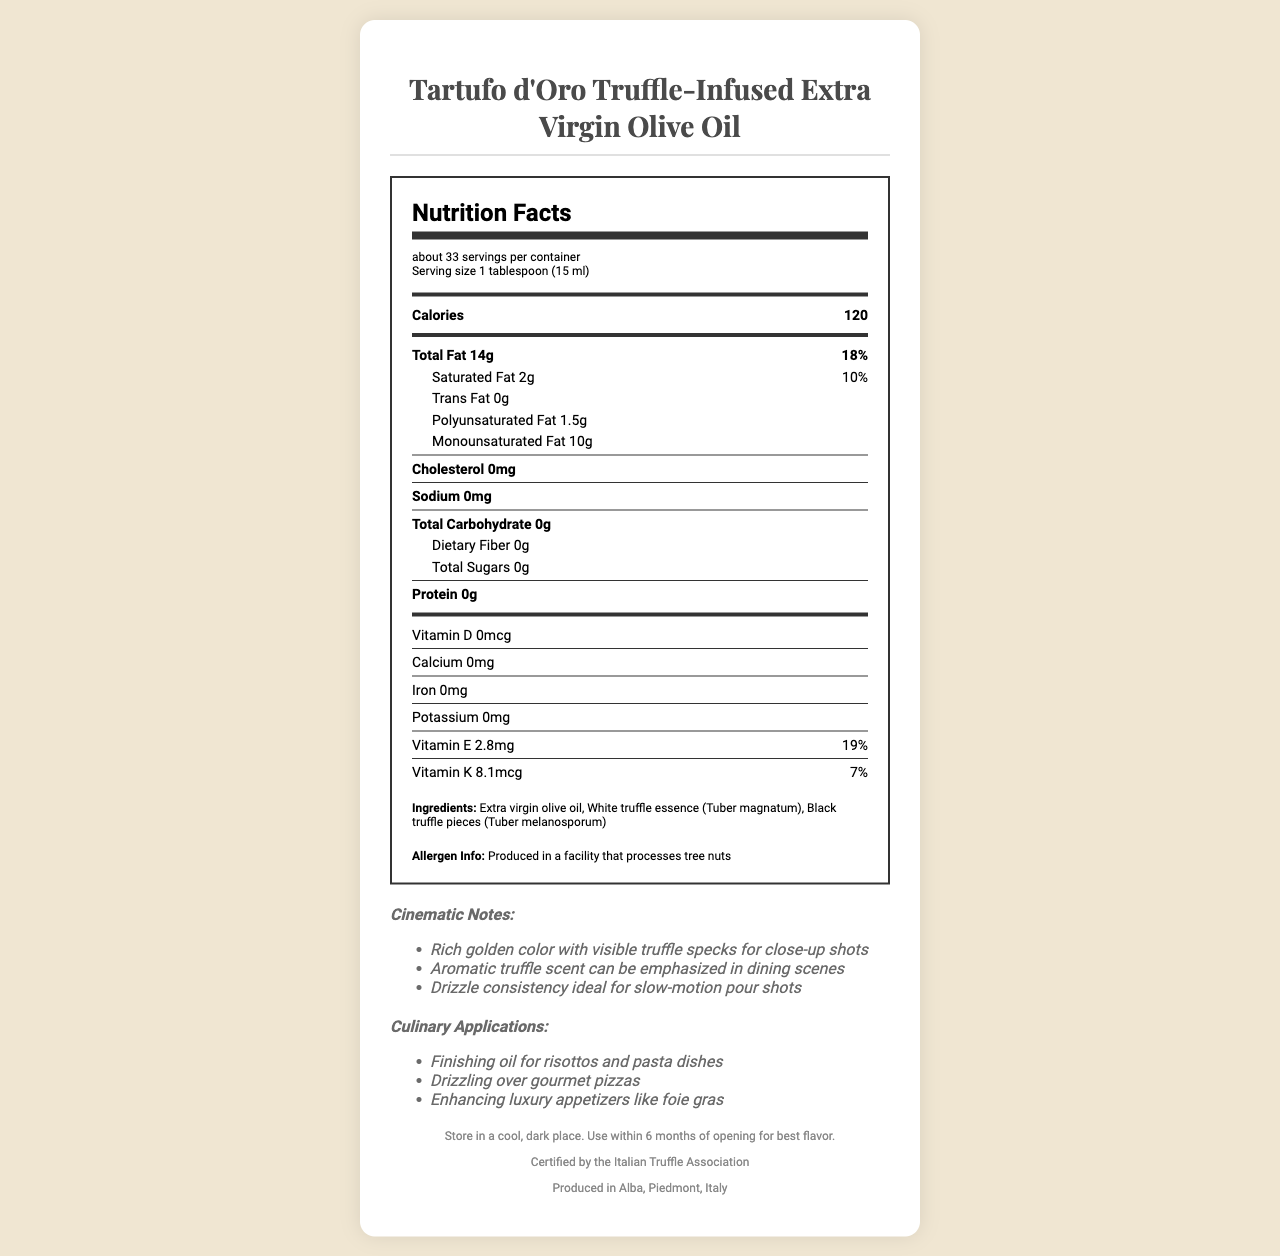who produces the Tartufo d'Oro Truffle-Infused Extra Virgin Olive Oil? The footer of the document states that the product is produced in Alba, Piedmont, Italy.
Answer: Produced in Alba, Piedmont, Italy how many calories are in one serving of the truffle-infused olive oil? The nutrition label specifies that there are 120 calories per 1 tablespoon (15 ml) serving.
Answer: 120 calories what is the main ingredient in this olive oil? The ingredients list starts with extra virgin olive oil, indicating it is the main ingredient.
Answer: Extra virgin olive oil how much saturated fat is in one serving? The nutrition label shows that a serving contains 2g of saturated fat.
Answer: 2g is there any cholesterol in the product? The nutrition label states that there is 0mg of cholesterol in the product.
Answer: No what is the daily value percentage of total fat per serving? The nutrition label lists the daily value of total fat as 18% per serving.
Answer: 18% does the product contain any dietary fiber? The nutrition label indicates that there is 0g of dietary fiber in the product.
Answer: No what is the serving size of the truffle-infused olive oil? The serving size is provided as 1 tablespoon (15 ml) on the nutrition label.
Answer: 1 tablespoon (15 ml) what is one culinary application of this olive oil mentioned in the document? The culinary applications section lists finishing oil for risottos and pasta dishes as one of the uses.
Answer: Finishing oil for risottos and pasta dishes why should this product be stored in a cool, dark place? The storage instructions state that storing in a cool, dark place helps retain the best flavor if used within 6 months of opening.
Answer: To maintain its best flavor within 6 months of opening what is the certification of the truffle-infused olive oil? The footer of the document mentions that the product is certified by the Italian Truffle Association.
Answer: Certified by the Italian Truffle Association how much vitamin E is in one serving of this product? A. 2.8mcg B. 0mg C. 2.8mg D. 8.1mcg The nutrition label specifies that there are 2.8mg of vitamin E per serving.
Answer: C. 2.8mg what seasoning does this olive oil not contain? A. Sodium B. Potassium C. Polyunsaturated fat D. Trans fat The nutrition label shows that there is 0g of trans fat, whereas other options are present in amounts.
Answer: D. Trans fat does the product contain tree nuts? The allergen information section states that it is produced in a facility that processes tree nuts, suggesting cross-contamination is possible.
Answer: Not directly, but produced in a facility that processes tree nuts is the olive oil ideal for drizzling over gourmet pizzas? The culinary applications section mentions that the olive oil can be used for drizzling over gourmet pizzas.
Answer: Yes summarize the main information presented in the document. The document comprehensively covers every aspect of the product from its nutritional content to its aesthetic and culinary uses, certification, and storage guidelines.
Answer: The document details the nutritional facts and culinary applications of Tartufo d'Oro Truffle-Infused Extra Virgin Olive Oil. It lists the serving size, calories, fat content breakdown, vitamins, ingredients, allergen info, cinematic notes for visual appeal in films, culinary uses, storage instructions, certification, and origin. what is the annual revenue of the product? The document does not provide any financial information, including annual revenue.
Answer: Not enough information 